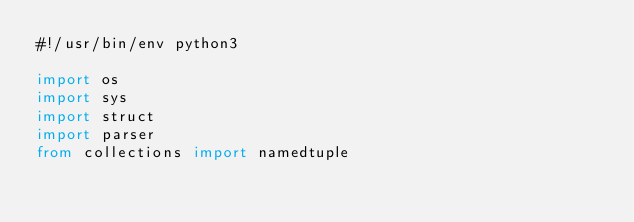<code> <loc_0><loc_0><loc_500><loc_500><_Python_>#!/usr/bin/env python3

import os
import sys
import struct
import parser
from collections import namedtuple</code> 